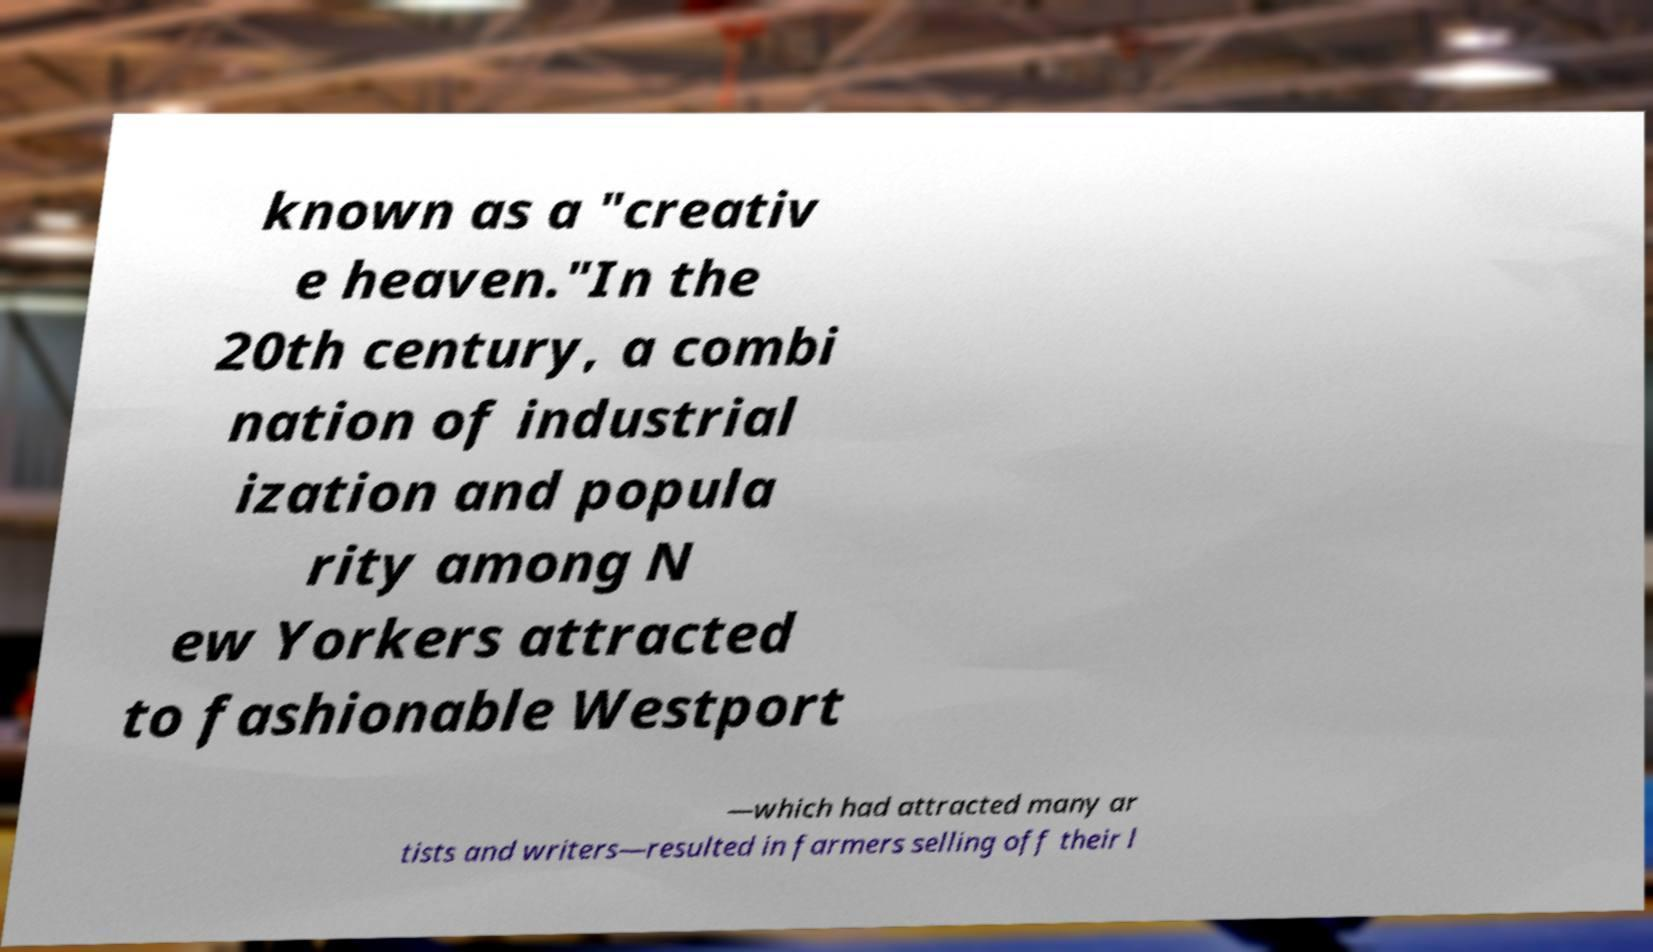Can you accurately transcribe the text from the provided image for me? known as a "creativ e heaven."In the 20th century, a combi nation of industrial ization and popula rity among N ew Yorkers attracted to fashionable Westport —which had attracted many ar tists and writers—resulted in farmers selling off their l 